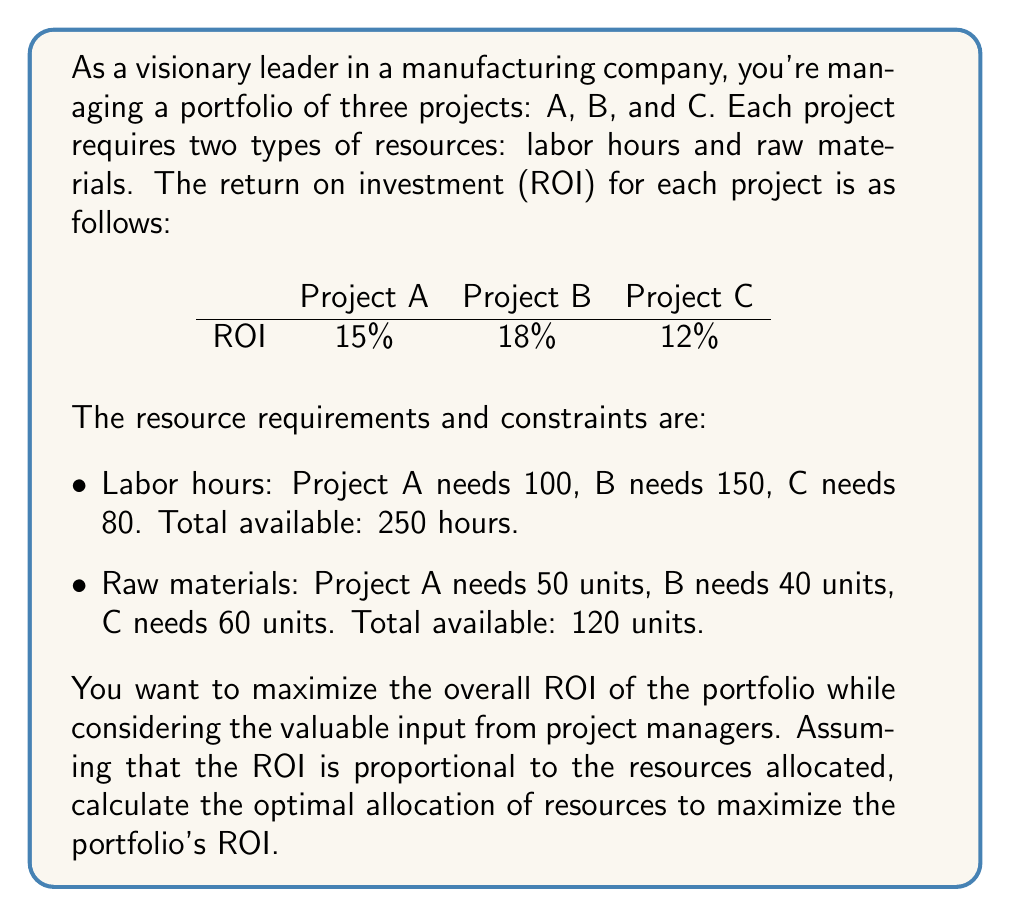Can you answer this question? To solve this problem, we'll use linear programming. Let's define our variables:

$x_A$, $x_B$, and $x_C$ represent the fraction of each project to be implemented.

Our objective function is to maximize the total ROI:

$$\text{Maximize } Z = 0.15x_A + 0.18x_B + 0.12x_C$$

Subject to the following constraints:

1. Labor hours: $100x_A + 150x_B + 80x_C \leq 250$
2. Raw materials: $50x_A + 40x_B + 60x_C \leq 120$
3. Non-negativity: $x_A, x_B, x_C \geq 0$
4. Full implementation limit: $x_A, x_B, x_C \leq 1$

To solve this, we can use the simplex method or a linear programming solver. The optimal solution is:

$x_A = 1$ (fully implement Project A)
$x_B = 0.6667$ (implement 2/3 of Project B)
$x_C = 0.3333$ (implement 1/3 of Project C)

Let's verify the constraints:

1. Labor hours: $100(1) + 150(0.6667) + 80(0.3333) = 250$ (exactly at the limit)
2. Raw materials: $50(1) + 40(0.6667) + 60(0.3333) = 96.67$ (below the limit of 120)

The maximum ROI achieved is:

$$Z = 0.15(1) + 0.18(0.6667) + 0.12(0.3333) = 0.274 \text{ or } 27.4\%$$

This solution suggests fully implementing Project A, two-thirds of Project B, and one-third of Project C to maximize the overall ROI while staying within resource constraints.
Answer: The optimal allocation of resources is:
Project A: 100% implementation
Project B: 66.67% implementation
Project C: 33.33% implementation

This allocation results in a maximum portfolio ROI of 27.4%. 